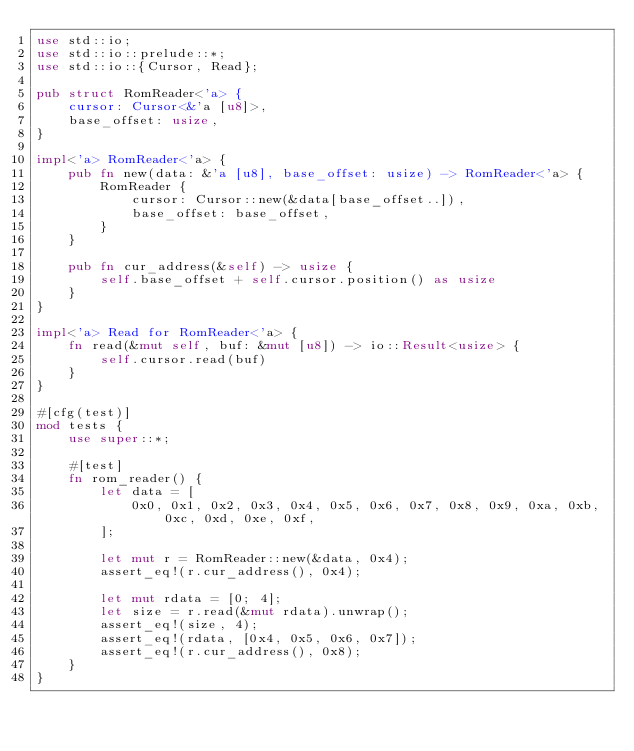Convert code to text. <code><loc_0><loc_0><loc_500><loc_500><_Rust_>use std::io;
use std::io::prelude::*;
use std::io::{Cursor, Read};

pub struct RomReader<'a> {
    cursor: Cursor<&'a [u8]>,
    base_offset: usize,
}

impl<'a> RomReader<'a> {
    pub fn new(data: &'a [u8], base_offset: usize) -> RomReader<'a> {
        RomReader {
            cursor: Cursor::new(&data[base_offset..]),
            base_offset: base_offset,
        }
    }

    pub fn cur_address(&self) -> usize {
        self.base_offset + self.cursor.position() as usize
    }
}

impl<'a> Read for RomReader<'a> {
    fn read(&mut self, buf: &mut [u8]) -> io::Result<usize> {
        self.cursor.read(buf)
    }
}

#[cfg(test)]
mod tests {
    use super::*;

    #[test]
    fn rom_reader() {
        let data = [
            0x0, 0x1, 0x2, 0x3, 0x4, 0x5, 0x6, 0x7, 0x8, 0x9, 0xa, 0xb, 0xc, 0xd, 0xe, 0xf,
        ];

        let mut r = RomReader::new(&data, 0x4);
        assert_eq!(r.cur_address(), 0x4);

        let mut rdata = [0; 4];
        let size = r.read(&mut rdata).unwrap();
        assert_eq!(size, 4);
        assert_eq!(rdata, [0x4, 0x5, 0x6, 0x7]);
        assert_eq!(r.cur_address(), 0x8);
    }
}
</code> 